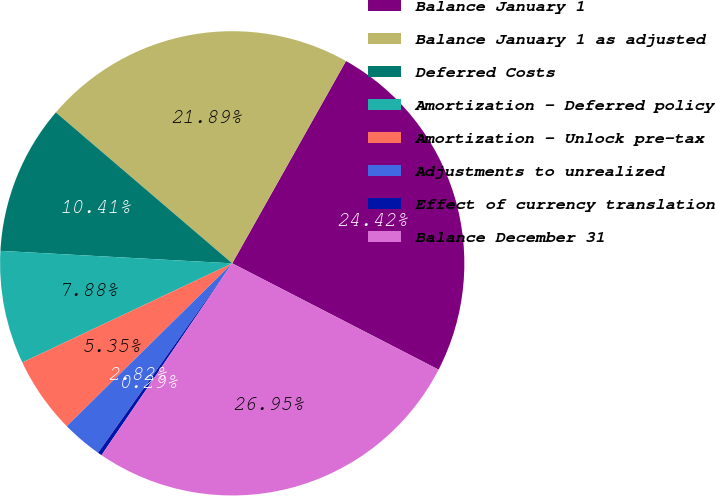<chart> <loc_0><loc_0><loc_500><loc_500><pie_chart><fcel>Balance January 1<fcel>Balance January 1 as adjusted<fcel>Deferred Costs<fcel>Amortization - Deferred policy<fcel>Amortization - Unlock pre-tax<fcel>Adjustments to unrealized<fcel>Effect of currency translation<fcel>Balance December 31<nl><fcel>24.42%<fcel>21.89%<fcel>10.41%<fcel>7.88%<fcel>5.35%<fcel>2.82%<fcel>0.29%<fcel>26.95%<nl></chart> 